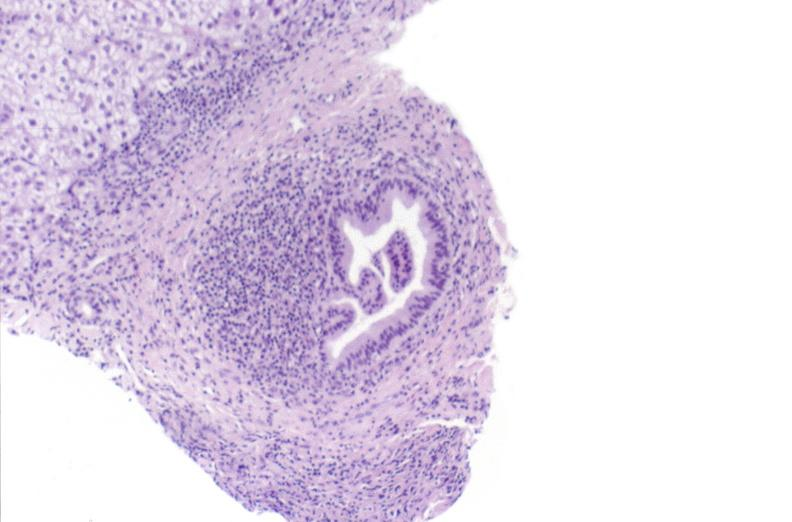what does this image show?
Answer the question using a single word or phrase. Primary biliary cirrhosis 